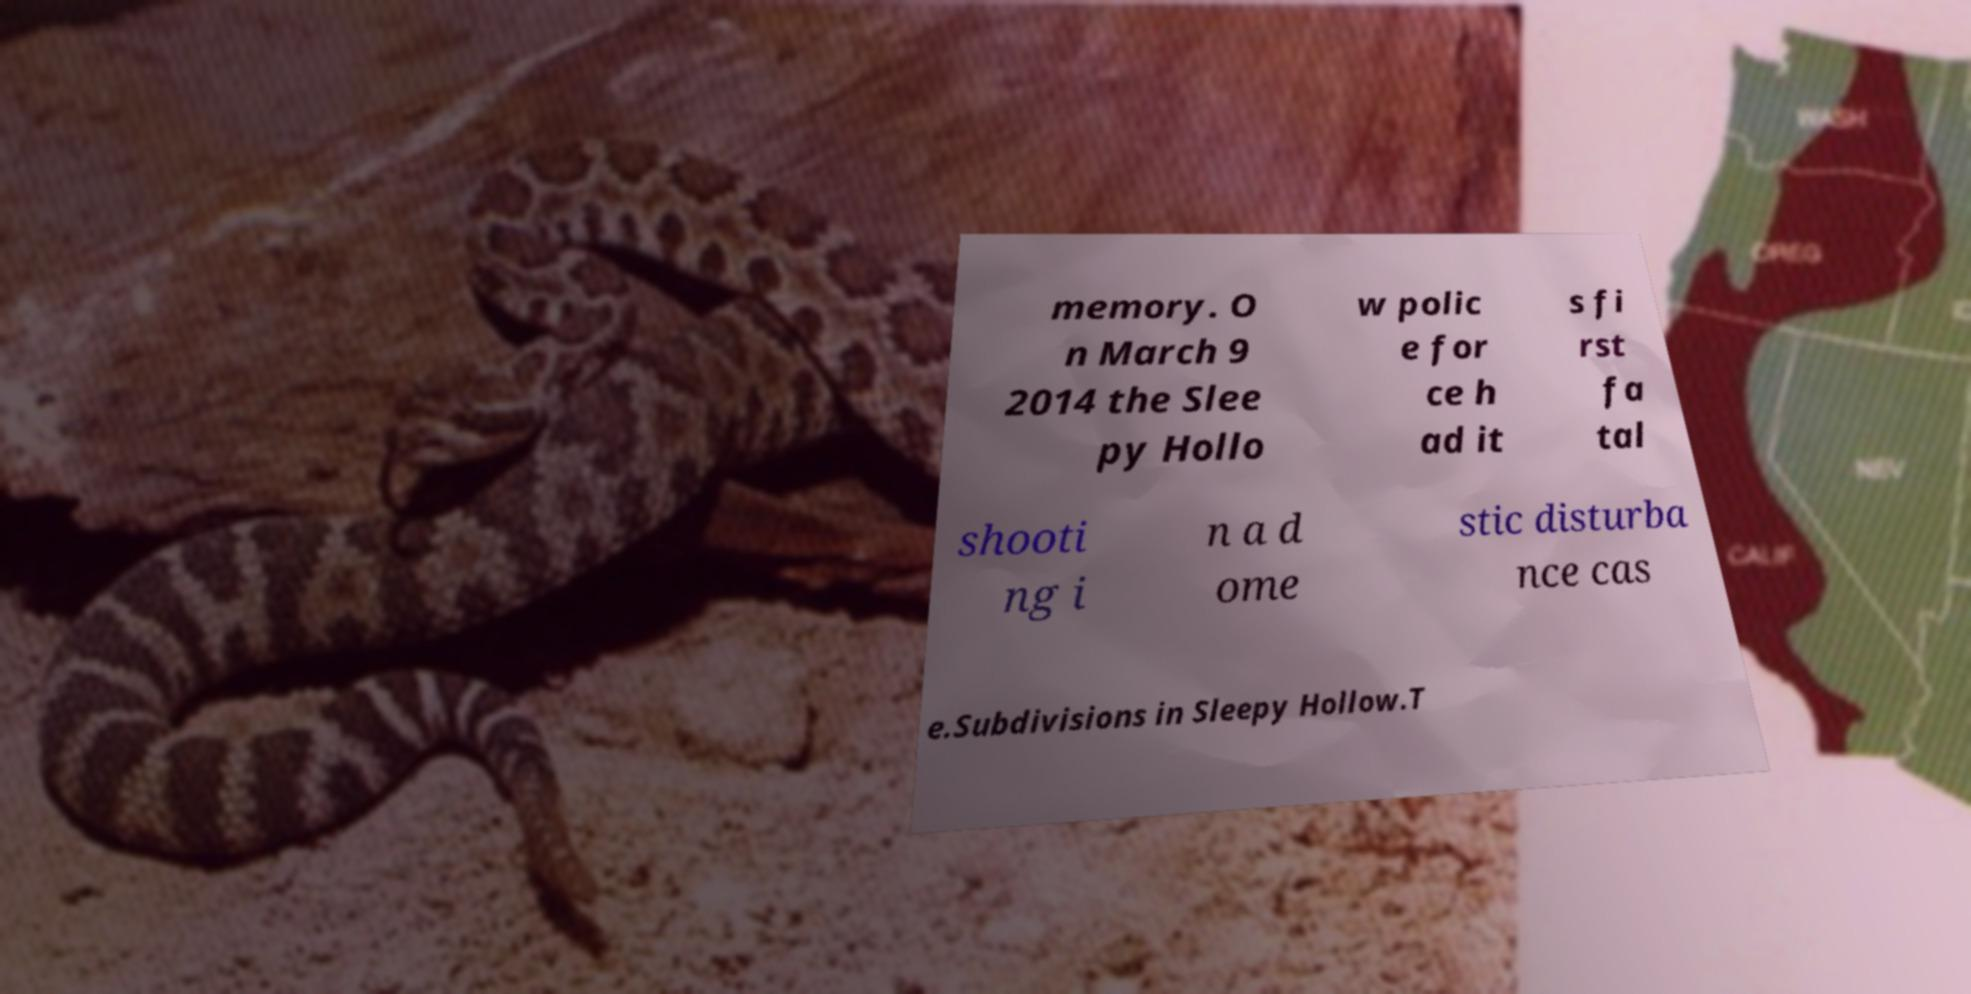I need the written content from this picture converted into text. Can you do that? memory. O n March 9 2014 the Slee py Hollo w polic e for ce h ad it s fi rst fa tal shooti ng i n a d ome stic disturba nce cas e.Subdivisions in Sleepy Hollow.T 